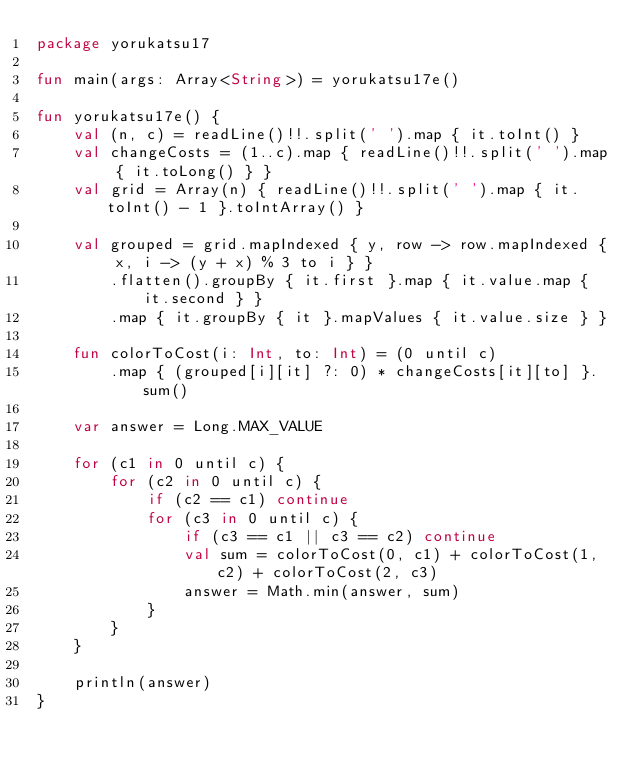Convert code to text. <code><loc_0><loc_0><loc_500><loc_500><_Kotlin_>package yorukatsu17

fun main(args: Array<String>) = yorukatsu17e()

fun yorukatsu17e() {
    val (n, c) = readLine()!!.split(' ').map { it.toInt() }
    val changeCosts = (1..c).map { readLine()!!.split(' ').map { it.toLong() } }
    val grid = Array(n) { readLine()!!.split(' ').map { it.toInt() - 1 }.toIntArray() }

    val grouped = grid.mapIndexed { y, row -> row.mapIndexed { x, i -> (y + x) % 3 to i } }
        .flatten().groupBy { it.first }.map { it.value.map { it.second } }
        .map { it.groupBy { it }.mapValues { it.value.size } }

    fun colorToCost(i: Int, to: Int) = (0 until c)
        .map { (grouped[i][it] ?: 0) * changeCosts[it][to] }.sum()

    var answer = Long.MAX_VALUE

    for (c1 in 0 until c) {
        for (c2 in 0 until c) {
            if (c2 == c1) continue
            for (c3 in 0 until c) {
                if (c3 == c1 || c3 == c2) continue
                val sum = colorToCost(0, c1) + colorToCost(1, c2) + colorToCost(2, c3)
                answer = Math.min(answer, sum)
            }
        }
    }

    println(answer)
}
</code> 